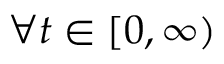Convert formula to latex. <formula><loc_0><loc_0><loc_500><loc_500>\forall t \in [ 0 , \infty )</formula> 